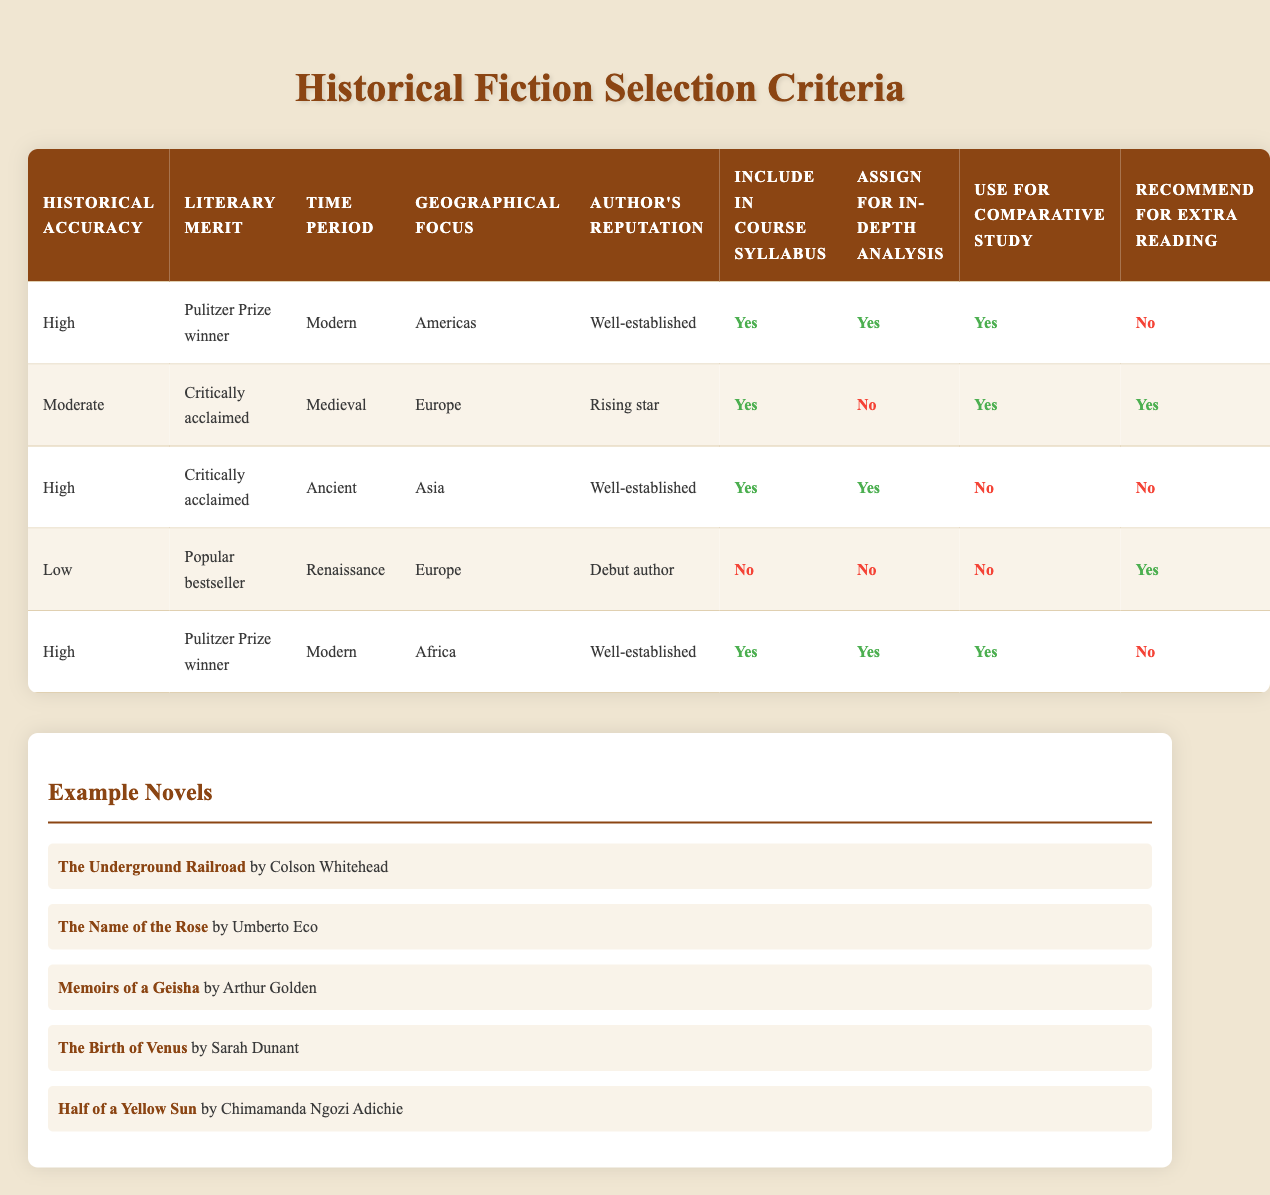What is the historical accuracy rating of "The Underground Railroad"? The table indicates that "The Underground Railroad" has a historical accuracy rating of "High", as it appears in the first row, which lists its conditions.
Answer: High How many novels have a high historical accuracy rating? The first and third rows of the table both have a historical accuracy rating of "High". Therefore, there are 2 novels that fall into this category.
Answer: 2 Do all novels written by well-established authors get included in the course syllabus? By looking at the table, we can see that not all rows with "Well-established" authors have a "Yes" under the "Include in course syllabus" column. Specifically, the novel "The Birth of Venus", which is by a rising star and has a low historical accuracy, is included while others are not.
Answer: No Which time periods are represented by books that receive an assignment for in-depth analysis? Referring to the table, we find that the time periods represented are Ancient, Medieval, and Modern. In detail, novels from the rows where in-depth analysis is assigned correspond to these time periods: Ancient (Memoirs of a Geisha), Medieval (The Name of the Rose), and Modern (The Underground Railroad and Half of a Yellow Sun).
Answer: Ancient, Medieval, Modern What action is taken when the author's reputation is a debut author and the historical accuracy is low? The table specifies that if the author's reputation is "Debut author" and the historical accuracy is "Low", then "Include in course syllabus" is "No". Additionally, there are also "No" responses for in-depth analysis, comparative study, while there is a "Yes" for extra reading.
Answer: No How many novels set in Africa with high historical accuracy do we have? The table shows that there are two novels with high historical accuracy, "Half of a Yellow Sun" is set in Africa, while "The Underground Railroad" is a modern context but set in Americas. In this case, we see only one novel that satisfies both conditions: high historical accuracy and set in Africa.
Answer: 1 Is "Memoirs of a Geisha" assigned for comparative study? By examining the conditions in the row for "Memoirs of a Geisha," we note that it has a response of "No" in the "Use for comparative study" column. Thus, it is not assigned for that purpose.
Answer: No For novels categorized as "Moderate" in historical accuracy, how many of them are also popular bestsellers? In the table, referencing the "Moderate" historical accuracy, only one novel, "The Birth of Venus," is categorized as a popular bestseller—indicating that there is just one.
Answer: 1 In total, how many books are listed that are set in the Americas? Looking through the table, the rows for "The Underground Railroad" and "Half of a Yellow Sun" indicate that both of these novels are set in the Americas. Therefore, there are a total of 2 novels listed that are set in the Americas.
Answer: 2 